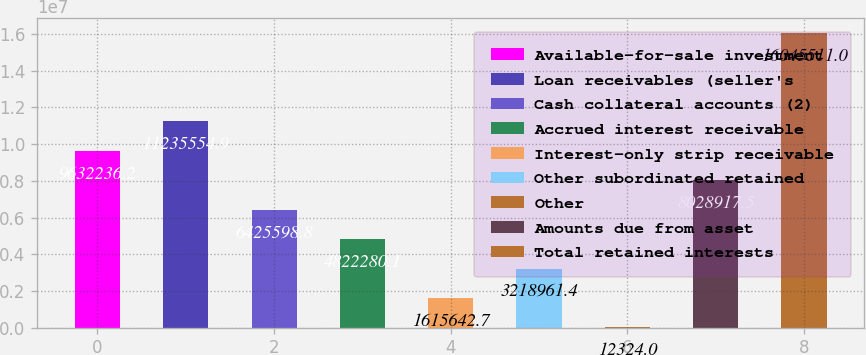Convert chart. <chart><loc_0><loc_0><loc_500><loc_500><bar_chart><fcel>Available-for-sale investment<fcel>Loan receivables (seller's<fcel>Cash collateral accounts (2)<fcel>Accrued interest receivable<fcel>Interest-only strip receivable<fcel>Other subordinated retained<fcel>Other<fcel>Amounts due from asset<fcel>Total retained interests<nl><fcel>9.63224e+06<fcel>1.12356e+07<fcel>6.4256e+06<fcel>4.82228e+06<fcel>1.61564e+06<fcel>3.21896e+06<fcel>12324<fcel>8.02892e+06<fcel>1.60455e+07<nl></chart> 